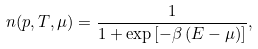<formula> <loc_0><loc_0><loc_500><loc_500>n ( p , T , \mu ) = \frac { 1 } { 1 + \exp \left [ - \beta \left ( E - \mu \right ) \right ] } ,</formula> 